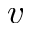<formula> <loc_0><loc_0><loc_500><loc_500>v</formula> 